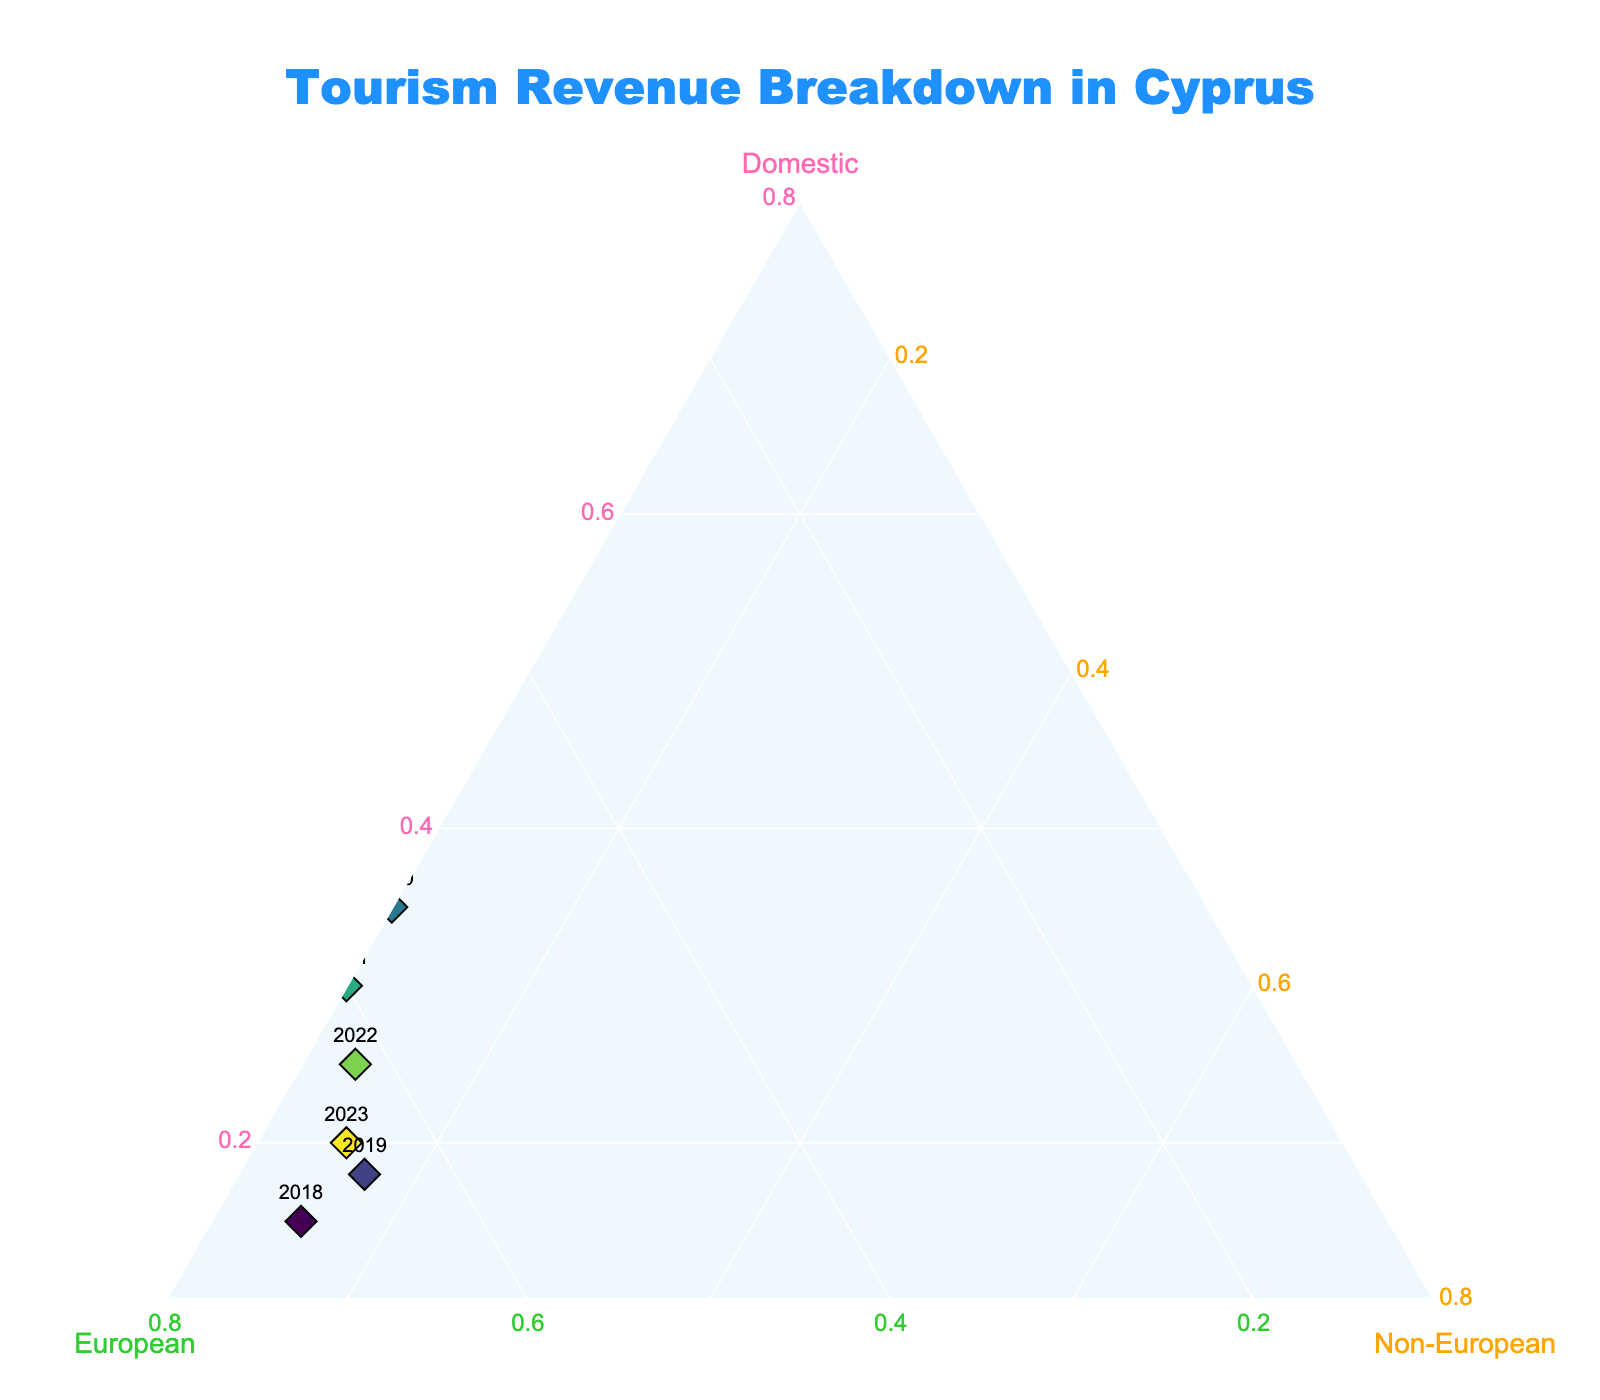what is the title of the plot? The title is located at the top of the plot and can be read directly.
Answer: Tourism Revenue Breakdown in Cyprus How many total data points are shown in the plot? Each year represents a data point, and counting the years from 2018 to 2023 gives the total number of data points.
Answer: 6 In which year did domestic visitors contribute the most to tourism revenue? The plot shows that 2020 has the highest percentage on the domestic axis.
Answer: 2020 What is the difference in the European contribution between 2020 and 2021? Locate the percentage for European visitors in 2020 and 2021, then subtract the 2021 value from the 2020 value (55 - 60) = -5.
Answer: -5 Which year had equal contributions from non-European and domestic visitors? From the plot, we can see that the year 2018 had equal contributions of 15% from both domestic and non-European visitors.
Answer: 2018 What is the average percentage of the European visitors’ contribution over the observed years? Sum the percentages for European visitors across all years and divide by the number of years: (70 + 65 + 55 + 60 + 62 + 65) / 6 = 62.83.
Answer: 62.83 Compare the non-European contribution in 2021 and 2023. Which year had a higher contribution? By checking the non-European axis, 2023 had a higher percentage (15%) compared to 2021 (10%).
Answer: 2023 Is there any year where the sum of domestic and European contributions is exactly 85%? Check each year’s domestic and European values. For 2019, 18% (domestic) + 65% (European) = 83%, but for 2020, 35% + 55% = 90% and for 2021, 30% + 60% = 90%.
Answer: No 